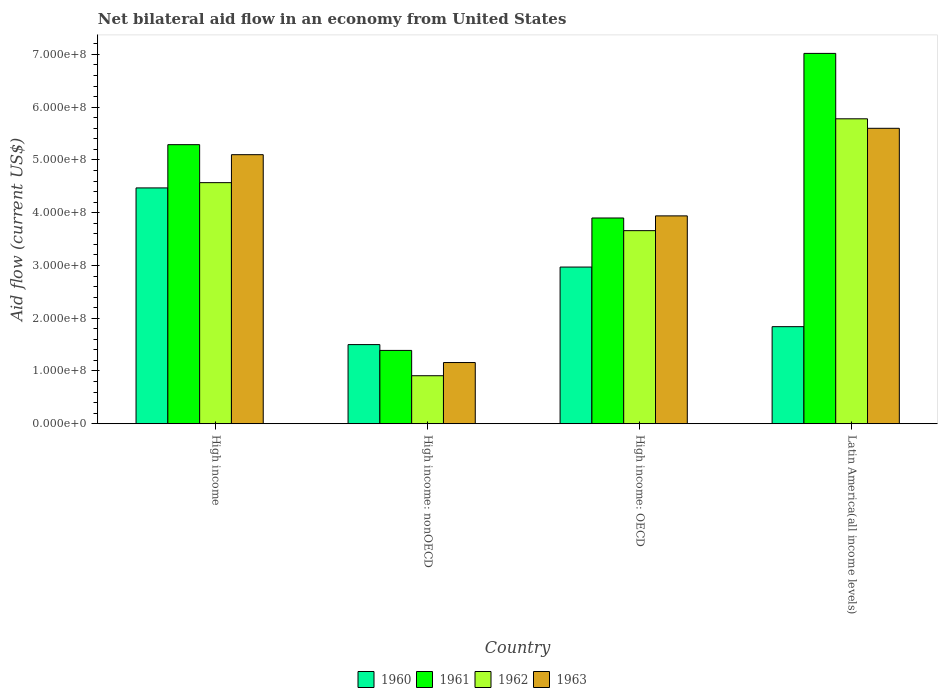How many different coloured bars are there?
Give a very brief answer. 4. Are the number of bars per tick equal to the number of legend labels?
Your answer should be very brief. Yes. What is the net bilateral aid flow in 1963 in High income?
Give a very brief answer. 5.10e+08. Across all countries, what is the maximum net bilateral aid flow in 1960?
Offer a terse response. 4.47e+08. Across all countries, what is the minimum net bilateral aid flow in 1963?
Ensure brevity in your answer.  1.16e+08. In which country was the net bilateral aid flow in 1962 maximum?
Give a very brief answer. Latin America(all income levels). In which country was the net bilateral aid flow in 1963 minimum?
Give a very brief answer. High income: nonOECD. What is the total net bilateral aid flow in 1961 in the graph?
Give a very brief answer. 1.76e+09. What is the difference between the net bilateral aid flow in 1960 in High income and that in High income: nonOECD?
Make the answer very short. 2.97e+08. What is the difference between the net bilateral aid flow in 1960 in High income and the net bilateral aid flow in 1962 in High income: OECD?
Your answer should be very brief. 8.10e+07. What is the average net bilateral aid flow in 1963 per country?
Provide a succinct answer. 3.95e+08. What is the difference between the net bilateral aid flow of/in 1960 and net bilateral aid flow of/in 1962 in High income?
Keep it short and to the point. -1.00e+07. What is the ratio of the net bilateral aid flow in 1963 in High income to that in High income: nonOECD?
Provide a succinct answer. 4.4. Is the net bilateral aid flow in 1960 in High income: OECD less than that in High income: nonOECD?
Give a very brief answer. No. What is the difference between the highest and the second highest net bilateral aid flow in 1961?
Offer a very short reply. 1.73e+08. What is the difference between the highest and the lowest net bilateral aid flow in 1961?
Offer a very short reply. 5.63e+08. In how many countries, is the net bilateral aid flow in 1963 greater than the average net bilateral aid flow in 1963 taken over all countries?
Your response must be concise. 2. Is the sum of the net bilateral aid flow in 1961 in High income and Latin America(all income levels) greater than the maximum net bilateral aid flow in 1962 across all countries?
Ensure brevity in your answer.  Yes. What does the 1st bar from the right in High income: nonOECD represents?
Give a very brief answer. 1963. Is it the case that in every country, the sum of the net bilateral aid flow in 1960 and net bilateral aid flow in 1962 is greater than the net bilateral aid flow in 1963?
Your answer should be very brief. Yes. How many bars are there?
Keep it short and to the point. 16. Are all the bars in the graph horizontal?
Offer a very short reply. No. What is the difference between two consecutive major ticks on the Y-axis?
Provide a succinct answer. 1.00e+08. Are the values on the major ticks of Y-axis written in scientific E-notation?
Keep it short and to the point. Yes. Does the graph contain any zero values?
Keep it short and to the point. No. How many legend labels are there?
Your response must be concise. 4. How are the legend labels stacked?
Provide a short and direct response. Horizontal. What is the title of the graph?
Make the answer very short. Net bilateral aid flow in an economy from United States. Does "1987" appear as one of the legend labels in the graph?
Make the answer very short. No. What is the label or title of the X-axis?
Your answer should be compact. Country. What is the label or title of the Y-axis?
Provide a succinct answer. Aid flow (current US$). What is the Aid flow (current US$) of 1960 in High income?
Offer a terse response. 4.47e+08. What is the Aid flow (current US$) of 1961 in High income?
Your answer should be very brief. 5.29e+08. What is the Aid flow (current US$) of 1962 in High income?
Ensure brevity in your answer.  4.57e+08. What is the Aid flow (current US$) in 1963 in High income?
Provide a succinct answer. 5.10e+08. What is the Aid flow (current US$) in 1960 in High income: nonOECD?
Make the answer very short. 1.50e+08. What is the Aid flow (current US$) of 1961 in High income: nonOECD?
Give a very brief answer. 1.39e+08. What is the Aid flow (current US$) in 1962 in High income: nonOECD?
Make the answer very short. 9.10e+07. What is the Aid flow (current US$) in 1963 in High income: nonOECD?
Offer a very short reply. 1.16e+08. What is the Aid flow (current US$) of 1960 in High income: OECD?
Ensure brevity in your answer.  2.97e+08. What is the Aid flow (current US$) of 1961 in High income: OECD?
Provide a succinct answer. 3.90e+08. What is the Aid flow (current US$) in 1962 in High income: OECD?
Provide a succinct answer. 3.66e+08. What is the Aid flow (current US$) of 1963 in High income: OECD?
Offer a terse response. 3.94e+08. What is the Aid flow (current US$) in 1960 in Latin America(all income levels)?
Give a very brief answer. 1.84e+08. What is the Aid flow (current US$) of 1961 in Latin America(all income levels)?
Offer a very short reply. 7.02e+08. What is the Aid flow (current US$) of 1962 in Latin America(all income levels)?
Your answer should be very brief. 5.78e+08. What is the Aid flow (current US$) in 1963 in Latin America(all income levels)?
Your answer should be compact. 5.60e+08. Across all countries, what is the maximum Aid flow (current US$) in 1960?
Offer a very short reply. 4.47e+08. Across all countries, what is the maximum Aid flow (current US$) in 1961?
Offer a very short reply. 7.02e+08. Across all countries, what is the maximum Aid flow (current US$) in 1962?
Provide a succinct answer. 5.78e+08. Across all countries, what is the maximum Aid flow (current US$) of 1963?
Offer a very short reply. 5.60e+08. Across all countries, what is the minimum Aid flow (current US$) in 1960?
Make the answer very short. 1.50e+08. Across all countries, what is the minimum Aid flow (current US$) of 1961?
Offer a very short reply. 1.39e+08. Across all countries, what is the minimum Aid flow (current US$) of 1962?
Ensure brevity in your answer.  9.10e+07. Across all countries, what is the minimum Aid flow (current US$) of 1963?
Ensure brevity in your answer.  1.16e+08. What is the total Aid flow (current US$) of 1960 in the graph?
Provide a short and direct response. 1.08e+09. What is the total Aid flow (current US$) of 1961 in the graph?
Make the answer very short. 1.76e+09. What is the total Aid flow (current US$) of 1962 in the graph?
Keep it short and to the point. 1.49e+09. What is the total Aid flow (current US$) in 1963 in the graph?
Your answer should be very brief. 1.58e+09. What is the difference between the Aid flow (current US$) of 1960 in High income and that in High income: nonOECD?
Provide a short and direct response. 2.97e+08. What is the difference between the Aid flow (current US$) in 1961 in High income and that in High income: nonOECD?
Give a very brief answer. 3.90e+08. What is the difference between the Aid flow (current US$) of 1962 in High income and that in High income: nonOECD?
Offer a very short reply. 3.66e+08. What is the difference between the Aid flow (current US$) in 1963 in High income and that in High income: nonOECD?
Offer a very short reply. 3.94e+08. What is the difference between the Aid flow (current US$) in 1960 in High income and that in High income: OECD?
Your answer should be very brief. 1.50e+08. What is the difference between the Aid flow (current US$) of 1961 in High income and that in High income: OECD?
Provide a short and direct response. 1.39e+08. What is the difference between the Aid flow (current US$) of 1962 in High income and that in High income: OECD?
Give a very brief answer. 9.10e+07. What is the difference between the Aid flow (current US$) in 1963 in High income and that in High income: OECD?
Your response must be concise. 1.16e+08. What is the difference between the Aid flow (current US$) of 1960 in High income and that in Latin America(all income levels)?
Make the answer very short. 2.63e+08. What is the difference between the Aid flow (current US$) of 1961 in High income and that in Latin America(all income levels)?
Your answer should be very brief. -1.73e+08. What is the difference between the Aid flow (current US$) in 1962 in High income and that in Latin America(all income levels)?
Offer a very short reply. -1.21e+08. What is the difference between the Aid flow (current US$) in 1963 in High income and that in Latin America(all income levels)?
Your answer should be very brief. -5.00e+07. What is the difference between the Aid flow (current US$) in 1960 in High income: nonOECD and that in High income: OECD?
Provide a short and direct response. -1.47e+08. What is the difference between the Aid flow (current US$) of 1961 in High income: nonOECD and that in High income: OECD?
Provide a short and direct response. -2.51e+08. What is the difference between the Aid flow (current US$) of 1962 in High income: nonOECD and that in High income: OECD?
Keep it short and to the point. -2.75e+08. What is the difference between the Aid flow (current US$) in 1963 in High income: nonOECD and that in High income: OECD?
Offer a very short reply. -2.78e+08. What is the difference between the Aid flow (current US$) in 1960 in High income: nonOECD and that in Latin America(all income levels)?
Give a very brief answer. -3.40e+07. What is the difference between the Aid flow (current US$) in 1961 in High income: nonOECD and that in Latin America(all income levels)?
Keep it short and to the point. -5.63e+08. What is the difference between the Aid flow (current US$) of 1962 in High income: nonOECD and that in Latin America(all income levels)?
Ensure brevity in your answer.  -4.87e+08. What is the difference between the Aid flow (current US$) in 1963 in High income: nonOECD and that in Latin America(all income levels)?
Offer a terse response. -4.44e+08. What is the difference between the Aid flow (current US$) of 1960 in High income: OECD and that in Latin America(all income levels)?
Make the answer very short. 1.13e+08. What is the difference between the Aid flow (current US$) of 1961 in High income: OECD and that in Latin America(all income levels)?
Offer a very short reply. -3.12e+08. What is the difference between the Aid flow (current US$) in 1962 in High income: OECD and that in Latin America(all income levels)?
Give a very brief answer. -2.12e+08. What is the difference between the Aid flow (current US$) of 1963 in High income: OECD and that in Latin America(all income levels)?
Offer a terse response. -1.66e+08. What is the difference between the Aid flow (current US$) of 1960 in High income and the Aid flow (current US$) of 1961 in High income: nonOECD?
Give a very brief answer. 3.08e+08. What is the difference between the Aid flow (current US$) in 1960 in High income and the Aid flow (current US$) in 1962 in High income: nonOECD?
Ensure brevity in your answer.  3.56e+08. What is the difference between the Aid flow (current US$) in 1960 in High income and the Aid flow (current US$) in 1963 in High income: nonOECD?
Offer a very short reply. 3.31e+08. What is the difference between the Aid flow (current US$) in 1961 in High income and the Aid flow (current US$) in 1962 in High income: nonOECD?
Offer a terse response. 4.38e+08. What is the difference between the Aid flow (current US$) in 1961 in High income and the Aid flow (current US$) in 1963 in High income: nonOECD?
Your answer should be very brief. 4.13e+08. What is the difference between the Aid flow (current US$) of 1962 in High income and the Aid flow (current US$) of 1963 in High income: nonOECD?
Provide a succinct answer. 3.41e+08. What is the difference between the Aid flow (current US$) of 1960 in High income and the Aid flow (current US$) of 1961 in High income: OECD?
Offer a very short reply. 5.70e+07. What is the difference between the Aid flow (current US$) in 1960 in High income and the Aid flow (current US$) in 1962 in High income: OECD?
Your answer should be compact. 8.10e+07. What is the difference between the Aid flow (current US$) of 1960 in High income and the Aid flow (current US$) of 1963 in High income: OECD?
Your response must be concise. 5.30e+07. What is the difference between the Aid flow (current US$) of 1961 in High income and the Aid flow (current US$) of 1962 in High income: OECD?
Your answer should be very brief. 1.63e+08. What is the difference between the Aid flow (current US$) of 1961 in High income and the Aid flow (current US$) of 1963 in High income: OECD?
Offer a very short reply. 1.35e+08. What is the difference between the Aid flow (current US$) of 1962 in High income and the Aid flow (current US$) of 1963 in High income: OECD?
Offer a terse response. 6.30e+07. What is the difference between the Aid flow (current US$) in 1960 in High income and the Aid flow (current US$) in 1961 in Latin America(all income levels)?
Your answer should be compact. -2.55e+08. What is the difference between the Aid flow (current US$) of 1960 in High income and the Aid flow (current US$) of 1962 in Latin America(all income levels)?
Your response must be concise. -1.31e+08. What is the difference between the Aid flow (current US$) in 1960 in High income and the Aid flow (current US$) in 1963 in Latin America(all income levels)?
Make the answer very short. -1.13e+08. What is the difference between the Aid flow (current US$) of 1961 in High income and the Aid flow (current US$) of 1962 in Latin America(all income levels)?
Offer a very short reply. -4.90e+07. What is the difference between the Aid flow (current US$) of 1961 in High income and the Aid flow (current US$) of 1963 in Latin America(all income levels)?
Your response must be concise. -3.10e+07. What is the difference between the Aid flow (current US$) of 1962 in High income and the Aid flow (current US$) of 1963 in Latin America(all income levels)?
Your answer should be compact. -1.03e+08. What is the difference between the Aid flow (current US$) of 1960 in High income: nonOECD and the Aid flow (current US$) of 1961 in High income: OECD?
Your answer should be very brief. -2.40e+08. What is the difference between the Aid flow (current US$) of 1960 in High income: nonOECD and the Aid flow (current US$) of 1962 in High income: OECD?
Offer a very short reply. -2.16e+08. What is the difference between the Aid flow (current US$) of 1960 in High income: nonOECD and the Aid flow (current US$) of 1963 in High income: OECD?
Your answer should be compact. -2.44e+08. What is the difference between the Aid flow (current US$) of 1961 in High income: nonOECD and the Aid flow (current US$) of 1962 in High income: OECD?
Your response must be concise. -2.27e+08. What is the difference between the Aid flow (current US$) in 1961 in High income: nonOECD and the Aid flow (current US$) in 1963 in High income: OECD?
Ensure brevity in your answer.  -2.55e+08. What is the difference between the Aid flow (current US$) in 1962 in High income: nonOECD and the Aid flow (current US$) in 1963 in High income: OECD?
Offer a very short reply. -3.03e+08. What is the difference between the Aid flow (current US$) in 1960 in High income: nonOECD and the Aid flow (current US$) in 1961 in Latin America(all income levels)?
Your answer should be very brief. -5.52e+08. What is the difference between the Aid flow (current US$) in 1960 in High income: nonOECD and the Aid flow (current US$) in 1962 in Latin America(all income levels)?
Keep it short and to the point. -4.28e+08. What is the difference between the Aid flow (current US$) in 1960 in High income: nonOECD and the Aid flow (current US$) in 1963 in Latin America(all income levels)?
Your answer should be very brief. -4.10e+08. What is the difference between the Aid flow (current US$) in 1961 in High income: nonOECD and the Aid flow (current US$) in 1962 in Latin America(all income levels)?
Provide a succinct answer. -4.39e+08. What is the difference between the Aid flow (current US$) in 1961 in High income: nonOECD and the Aid flow (current US$) in 1963 in Latin America(all income levels)?
Provide a succinct answer. -4.21e+08. What is the difference between the Aid flow (current US$) in 1962 in High income: nonOECD and the Aid flow (current US$) in 1963 in Latin America(all income levels)?
Offer a very short reply. -4.69e+08. What is the difference between the Aid flow (current US$) of 1960 in High income: OECD and the Aid flow (current US$) of 1961 in Latin America(all income levels)?
Your response must be concise. -4.05e+08. What is the difference between the Aid flow (current US$) of 1960 in High income: OECD and the Aid flow (current US$) of 1962 in Latin America(all income levels)?
Ensure brevity in your answer.  -2.81e+08. What is the difference between the Aid flow (current US$) of 1960 in High income: OECD and the Aid flow (current US$) of 1963 in Latin America(all income levels)?
Your answer should be compact. -2.63e+08. What is the difference between the Aid flow (current US$) of 1961 in High income: OECD and the Aid flow (current US$) of 1962 in Latin America(all income levels)?
Offer a very short reply. -1.88e+08. What is the difference between the Aid flow (current US$) of 1961 in High income: OECD and the Aid flow (current US$) of 1963 in Latin America(all income levels)?
Your response must be concise. -1.70e+08. What is the difference between the Aid flow (current US$) in 1962 in High income: OECD and the Aid flow (current US$) in 1963 in Latin America(all income levels)?
Give a very brief answer. -1.94e+08. What is the average Aid flow (current US$) of 1960 per country?
Keep it short and to the point. 2.70e+08. What is the average Aid flow (current US$) in 1961 per country?
Ensure brevity in your answer.  4.40e+08. What is the average Aid flow (current US$) of 1962 per country?
Provide a short and direct response. 3.73e+08. What is the average Aid flow (current US$) in 1963 per country?
Provide a succinct answer. 3.95e+08. What is the difference between the Aid flow (current US$) of 1960 and Aid flow (current US$) of 1961 in High income?
Keep it short and to the point. -8.20e+07. What is the difference between the Aid flow (current US$) in 1960 and Aid flow (current US$) in 1962 in High income?
Offer a terse response. -1.00e+07. What is the difference between the Aid flow (current US$) of 1960 and Aid flow (current US$) of 1963 in High income?
Offer a very short reply. -6.30e+07. What is the difference between the Aid flow (current US$) of 1961 and Aid flow (current US$) of 1962 in High income?
Provide a short and direct response. 7.20e+07. What is the difference between the Aid flow (current US$) of 1961 and Aid flow (current US$) of 1963 in High income?
Keep it short and to the point. 1.90e+07. What is the difference between the Aid flow (current US$) in 1962 and Aid flow (current US$) in 1963 in High income?
Make the answer very short. -5.30e+07. What is the difference between the Aid flow (current US$) in 1960 and Aid flow (current US$) in 1961 in High income: nonOECD?
Make the answer very short. 1.10e+07. What is the difference between the Aid flow (current US$) of 1960 and Aid flow (current US$) of 1962 in High income: nonOECD?
Make the answer very short. 5.90e+07. What is the difference between the Aid flow (current US$) of 1960 and Aid flow (current US$) of 1963 in High income: nonOECD?
Your response must be concise. 3.40e+07. What is the difference between the Aid flow (current US$) of 1961 and Aid flow (current US$) of 1962 in High income: nonOECD?
Keep it short and to the point. 4.80e+07. What is the difference between the Aid flow (current US$) of 1961 and Aid flow (current US$) of 1963 in High income: nonOECD?
Your answer should be very brief. 2.30e+07. What is the difference between the Aid flow (current US$) of 1962 and Aid flow (current US$) of 1963 in High income: nonOECD?
Ensure brevity in your answer.  -2.50e+07. What is the difference between the Aid flow (current US$) of 1960 and Aid flow (current US$) of 1961 in High income: OECD?
Give a very brief answer. -9.30e+07. What is the difference between the Aid flow (current US$) in 1960 and Aid flow (current US$) in 1962 in High income: OECD?
Give a very brief answer. -6.90e+07. What is the difference between the Aid flow (current US$) in 1960 and Aid flow (current US$) in 1963 in High income: OECD?
Make the answer very short. -9.70e+07. What is the difference between the Aid flow (current US$) in 1961 and Aid flow (current US$) in 1962 in High income: OECD?
Your answer should be compact. 2.40e+07. What is the difference between the Aid flow (current US$) of 1962 and Aid flow (current US$) of 1963 in High income: OECD?
Offer a terse response. -2.80e+07. What is the difference between the Aid flow (current US$) in 1960 and Aid flow (current US$) in 1961 in Latin America(all income levels)?
Offer a terse response. -5.18e+08. What is the difference between the Aid flow (current US$) of 1960 and Aid flow (current US$) of 1962 in Latin America(all income levels)?
Offer a very short reply. -3.94e+08. What is the difference between the Aid flow (current US$) in 1960 and Aid flow (current US$) in 1963 in Latin America(all income levels)?
Make the answer very short. -3.76e+08. What is the difference between the Aid flow (current US$) of 1961 and Aid flow (current US$) of 1962 in Latin America(all income levels)?
Your response must be concise. 1.24e+08. What is the difference between the Aid flow (current US$) of 1961 and Aid flow (current US$) of 1963 in Latin America(all income levels)?
Your response must be concise. 1.42e+08. What is the difference between the Aid flow (current US$) of 1962 and Aid flow (current US$) of 1963 in Latin America(all income levels)?
Make the answer very short. 1.80e+07. What is the ratio of the Aid flow (current US$) of 1960 in High income to that in High income: nonOECD?
Make the answer very short. 2.98. What is the ratio of the Aid flow (current US$) of 1961 in High income to that in High income: nonOECD?
Offer a very short reply. 3.81. What is the ratio of the Aid flow (current US$) of 1962 in High income to that in High income: nonOECD?
Offer a terse response. 5.02. What is the ratio of the Aid flow (current US$) of 1963 in High income to that in High income: nonOECD?
Offer a terse response. 4.4. What is the ratio of the Aid flow (current US$) in 1960 in High income to that in High income: OECD?
Give a very brief answer. 1.51. What is the ratio of the Aid flow (current US$) in 1961 in High income to that in High income: OECD?
Offer a terse response. 1.36. What is the ratio of the Aid flow (current US$) of 1962 in High income to that in High income: OECD?
Provide a succinct answer. 1.25. What is the ratio of the Aid flow (current US$) in 1963 in High income to that in High income: OECD?
Provide a short and direct response. 1.29. What is the ratio of the Aid flow (current US$) of 1960 in High income to that in Latin America(all income levels)?
Your answer should be very brief. 2.43. What is the ratio of the Aid flow (current US$) of 1961 in High income to that in Latin America(all income levels)?
Your answer should be compact. 0.75. What is the ratio of the Aid flow (current US$) in 1962 in High income to that in Latin America(all income levels)?
Keep it short and to the point. 0.79. What is the ratio of the Aid flow (current US$) in 1963 in High income to that in Latin America(all income levels)?
Provide a succinct answer. 0.91. What is the ratio of the Aid flow (current US$) of 1960 in High income: nonOECD to that in High income: OECD?
Ensure brevity in your answer.  0.51. What is the ratio of the Aid flow (current US$) in 1961 in High income: nonOECD to that in High income: OECD?
Ensure brevity in your answer.  0.36. What is the ratio of the Aid flow (current US$) of 1962 in High income: nonOECD to that in High income: OECD?
Offer a very short reply. 0.25. What is the ratio of the Aid flow (current US$) in 1963 in High income: nonOECD to that in High income: OECD?
Your response must be concise. 0.29. What is the ratio of the Aid flow (current US$) in 1960 in High income: nonOECD to that in Latin America(all income levels)?
Provide a short and direct response. 0.82. What is the ratio of the Aid flow (current US$) in 1961 in High income: nonOECD to that in Latin America(all income levels)?
Your response must be concise. 0.2. What is the ratio of the Aid flow (current US$) in 1962 in High income: nonOECD to that in Latin America(all income levels)?
Offer a terse response. 0.16. What is the ratio of the Aid flow (current US$) in 1963 in High income: nonOECD to that in Latin America(all income levels)?
Offer a very short reply. 0.21. What is the ratio of the Aid flow (current US$) of 1960 in High income: OECD to that in Latin America(all income levels)?
Provide a succinct answer. 1.61. What is the ratio of the Aid flow (current US$) of 1961 in High income: OECD to that in Latin America(all income levels)?
Offer a very short reply. 0.56. What is the ratio of the Aid flow (current US$) in 1962 in High income: OECD to that in Latin America(all income levels)?
Your response must be concise. 0.63. What is the ratio of the Aid flow (current US$) in 1963 in High income: OECD to that in Latin America(all income levels)?
Your answer should be compact. 0.7. What is the difference between the highest and the second highest Aid flow (current US$) in 1960?
Provide a short and direct response. 1.50e+08. What is the difference between the highest and the second highest Aid flow (current US$) of 1961?
Make the answer very short. 1.73e+08. What is the difference between the highest and the second highest Aid flow (current US$) in 1962?
Give a very brief answer. 1.21e+08. What is the difference between the highest and the second highest Aid flow (current US$) of 1963?
Keep it short and to the point. 5.00e+07. What is the difference between the highest and the lowest Aid flow (current US$) in 1960?
Your answer should be very brief. 2.97e+08. What is the difference between the highest and the lowest Aid flow (current US$) of 1961?
Ensure brevity in your answer.  5.63e+08. What is the difference between the highest and the lowest Aid flow (current US$) of 1962?
Your answer should be compact. 4.87e+08. What is the difference between the highest and the lowest Aid flow (current US$) in 1963?
Give a very brief answer. 4.44e+08. 